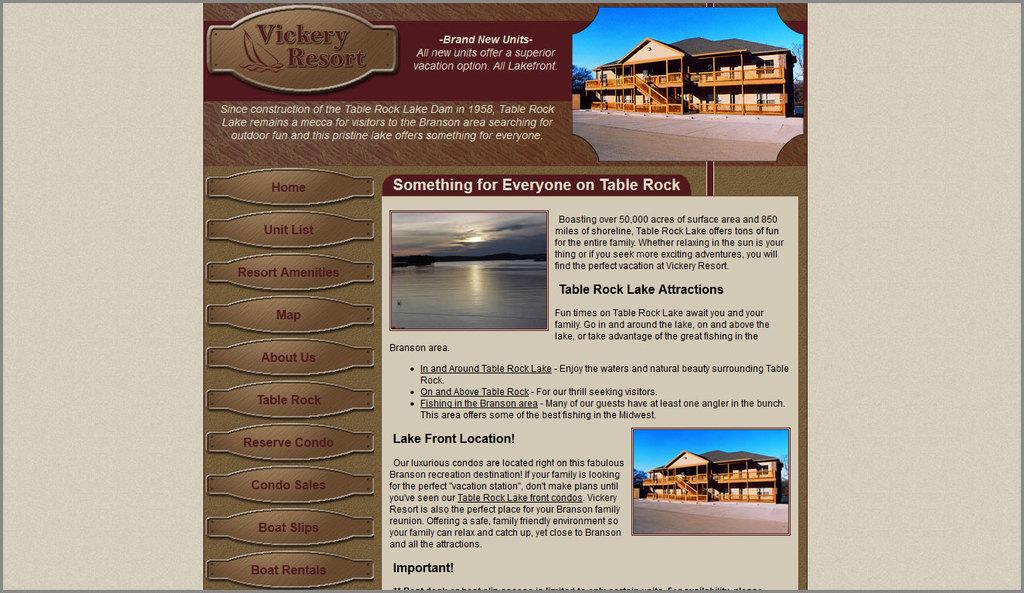What is the website's name?
Ensure brevity in your answer.  Vickery resort. 